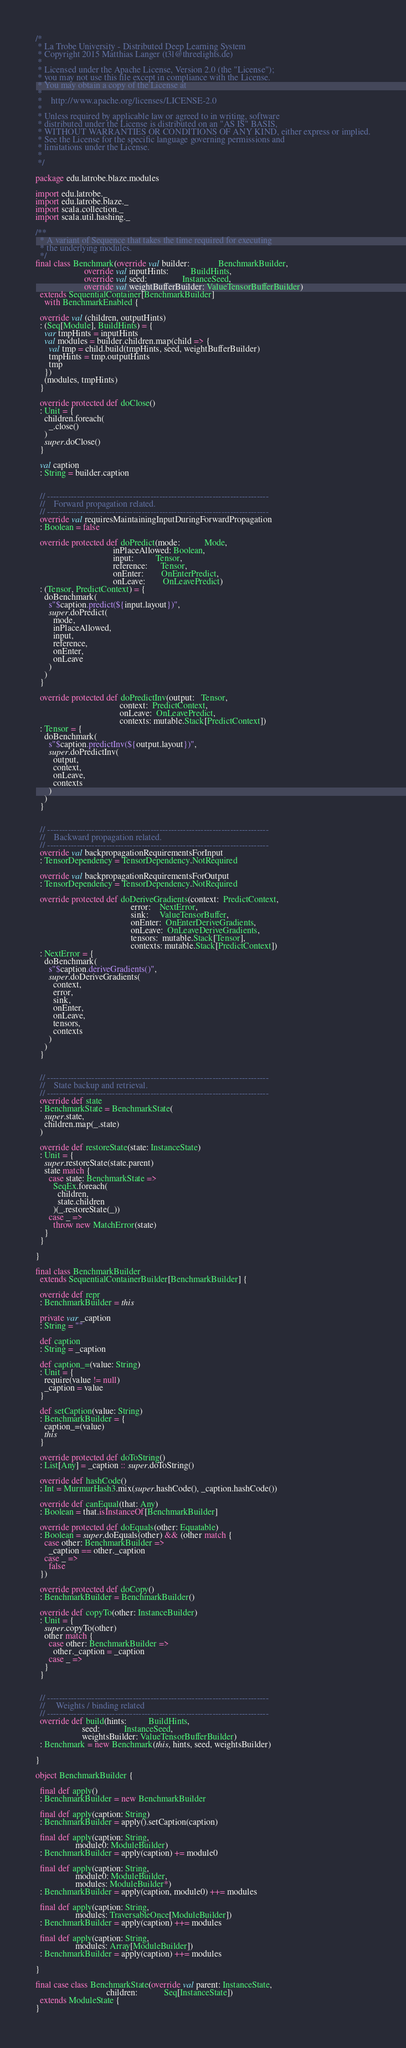Convert code to text. <code><loc_0><loc_0><loc_500><loc_500><_Scala_>/*
 * La Trobe University - Distributed Deep Learning System
 * Copyright 2015 Matthias Langer (t3l@threelights.de)
 *
 * Licensed under the Apache License, Version 2.0 (the "License");
 * you may not use this file except in compliance with the License.
 * You may obtain a copy of the License at
 *
 *    http://www.apache.org/licenses/LICENSE-2.0
 *
 * Unless required by applicable law or agreed to in writing, software
 * distributed under the License is distributed on an "AS IS" BASIS,
 * WITHOUT WARRANTIES OR CONDITIONS OF ANY KIND, either express or implied.
 * See the License for the specific language governing permissions and
 * limitations under the License.
 *
 */

package edu.latrobe.blaze.modules

import edu.latrobe._
import edu.latrobe.blaze._
import scala.collection._
import scala.util.hashing._

/**
  * A variant of Sequence that takes the time required for executing
  * the underlying modules.
  */
final class Benchmark(override val builder:             BenchmarkBuilder,
                      override val inputHints:          BuildHints,
                      override val seed:                InstanceSeed,
                      override val weightBufferBuilder: ValueTensorBufferBuilder)
  extends SequentialContainer[BenchmarkBuilder]
    with BenchmarkEnabled {

  override val (children, outputHints)
  : (Seq[Module], BuildHints) = {
    var tmpHints = inputHints
    val modules = builder.children.map(child => {
      val tmp = child.build(tmpHints, seed, weightBufferBuilder)
      tmpHints = tmp.outputHints
      tmp
    })
    (modules, tmpHints)
  }

  override protected def doClose()
  : Unit = {
    children.foreach(
      _.close()
    )
    super.doClose()
  }

  val caption
  : String = builder.caption


  // ---------------------------------------------------------------------------
  //    Forward propagation related.
  // ---------------------------------------------------------------------------
  override val requiresMaintainingInputDuringForwardPropagation
  : Boolean = false

  override protected def doPredict(mode:           Mode,
                                   inPlaceAllowed: Boolean,
                                   input:          Tensor,
                                   reference:      Tensor,
                                   onEnter:        OnEnterPredict,
                                   onLeave:        OnLeavePredict)
  : (Tensor, PredictContext) = {
    doBenchmark(
      s"$caption.predict(${input.layout})",
      super.doPredict(
        mode,
        inPlaceAllowed,
        input,
        reference,
        onEnter,
        onLeave
      )
    )
  }

  override protected def doPredictInv(output:   Tensor,
                                      context:  PredictContext,
                                      onLeave:  OnLeavePredict,
                                      contexts: mutable.Stack[PredictContext])
  : Tensor = {
    doBenchmark(
      s"$caption.predictInv(${output.layout})",
      super.doPredictInv(
        output,
        context,
        onLeave,
        contexts
      )
    )
  }


  // ---------------------------------------------------------------------------
  //    Backward propagation related.
  // ---------------------------------------------------------------------------
  override val backpropagationRequirementsForInput
  : TensorDependency = TensorDependency.NotRequired

  override val backpropagationRequirementsForOutput
  : TensorDependency = TensorDependency.NotRequired

  override protected def doDeriveGradients(context:  PredictContext,
                                           error:    NextError,
                                           sink:     ValueTensorBuffer,
                                           onEnter:  OnEnterDeriveGradients,
                                           onLeave:  OnLeaveDeriveGradients,
                                           tensors:  mutable.Stack[Tensor],
                                           contexts: mutable.Stack[PredictContext])
  : NextError = {
    doBenchmark(
      s"$caption.deriveGradients()",
      super.doDeriveGradients(
        context,
        error,
        sink,
        onEnter,
        onLeave,
        tensors,
        contexts
      )
    )
  }


  // ---------------------------------------------------------------------------
  //    State backup and retrieval.
  // ---------------------------------------------------------------------------
  override def state
  : BenchmarkState = BenchmarkState(
    super.state,
    children.map(_.state)
  )

  override def restoreState(state: InstanceState)
  : Unit = {
    super.restoreState(state.parent)
    state match {
      case state: BenchmarkState =>
        SeqEx.foreach(
          children,
          state.children
        )(_.restoreState(_))
      case _ =>
        throw new MatchError(state)
    }
  }

}

final class BenchmarkBuilder
  extends SequentialContainerBuilder[BenchmarkBuilder] {

  override def repr
  : BenchmarkBuilder = this

  private var _caption
  : String = ""

  def caption
  : String = _caption

  def caption_=(value: String)
  : Unit = {
    require(value != null)
    _caption = value
  }

  def setCaption(value: String)
  : BenchmarkBuilder = {
    caption_=(value)
    this
  }

  override protected def doToString()
  : List[Any] = _caption :: super.doToString()

  override def hashCode()
  : Int = MurmurHash3.mix(super.hashCode(), _caption.hashCode())

  override def canEqual(that: Any)
  : Boolean = that.isInstanceOf[BenchmarkBuilder]

  override protected def doEquals(other: Equatable)
  : Boolean = super.doEquals(other) && (other match {
    case other: BenchmarkBuilder =>
      _caption == other._caption
    case _ =>
      false
  })

  override protected def doCopy()
  : BenchmarkBuilder = BenchmarkBuilder()

  override def copyTo(other: InstanceBuilder)
  : Unit = {
    super.copyTo(other)
    other match {
      case other: BenchmarkBuilder =>
        other._caption = _caption
      case _ =>
    }
  }


  // ---------------------------------------------------------------------------
  //     Weights / binding related
  // ---------------------------------------------------------------------------
  override def build(hints:          BuildHints,
                     seed:           InstanceSeed,
                     weightsBuilder: ValueTensorBufferBuilder)
  : Benchmark = new Benchmark(this, hints, seed, weightsBuilder)

}

object BenchmarkBuilder {

  final def apply()
  : BenchmarkBuilder = new BenchmarkBuilder

  final def apply(caption: String)
  : BenchmarkBuilder = apply().setCaption(caption)

  final def apply(caption: String,
                  module0: ModuleBuilder)
  : BenchmarkBuilder = apply(caption) += module0

  final def apply(caption: String,
                  module0: ModuleBuilder,
                  modules: ModuleBuilder*)
  : BenchmarkBuilder = apply(caption, module0) ++= modules

  final def apply(caption: String,
                  modules: TraversableOnce[ModuleBuilder])
  : BenchmarkBuilder = apply(caption) ++= modules

  final def apply(caption: String,
                  modules: Array[ModuleBuilder])
  : BenchmarkBuilder = apply(caption) ++= modules

}

final case class BenchmarkState(override val parent: InstanceState,
                                children:            Seq[InstanceState])
  extends ModuleState {
}
</code> 